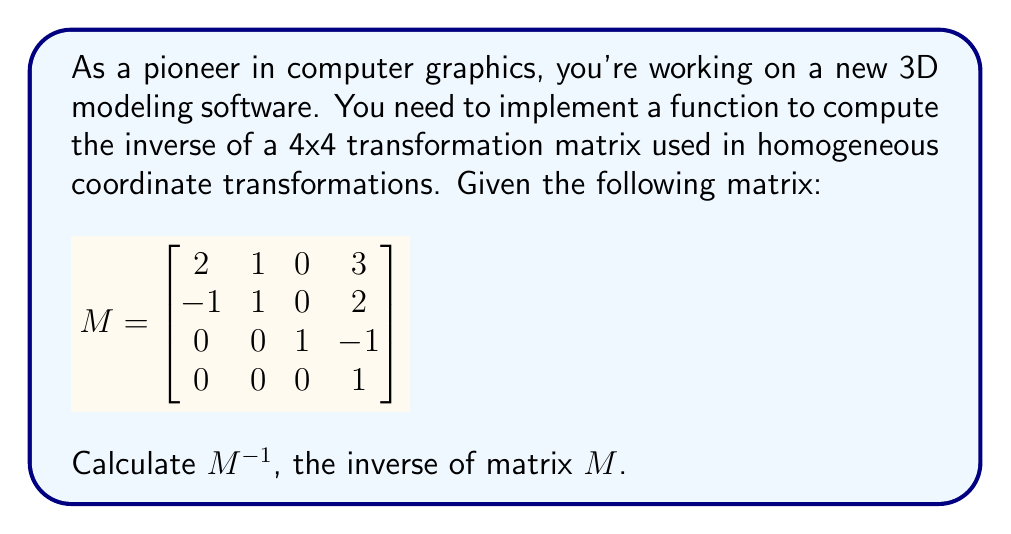Can you solve this math problem? To find the inverse of a 4x4 matrix, we can use the following steps:

1) First, we observe that $M$ is a special case of an affine transformation matrix, where the last row is $[0, 0, 0, 1]$. This allows us to use a more efficient method than the general inverse calculation.

2) We can partition the matrix into blocks:

   $$M = \begin{bmatrix} A & t \\ 0 & 1 \end{bmatrix}$$

   where $A$ is a 3x3 matrix, and $t$ is a 3x1 translation vector.

3) For this form, the inverse is given by:

   $$M^{-1} = \begin{bmatrix} A^{-1} & -A^{-1}t \\ 0 & 1 \end{bmatrix}$$

4) Let's find $A^{-1}$:

   $$A = \begin{bmatrix}
   2 & 1 & 0 \\
   -1 & 1 & 0 \\
   0 & 0 & 1
   \end{bmatrix}$$

5) We can see that $A$ is block diagonal, so we only need to invert the 2x2 upper-left block:

   $$\begin{bmatrix}
   2 & 1 \\
   -1 & 1
   \end{bmatrix}^{-1} = \frac{1}{3}\begin{bmatrix}
   1 & -1 \\
   1 & 2
   \end{bmatrix}$$

6) Therefore:

   $$A^{-1} = \begin{bmatrix}
   1/3 & -1/3 & 0 \\
   1/3 & 2/3 & 0 \\
   0 & 0 & 1
   \end{bmatrix}$$

7) Now, let's compute $-A^{-1}t$:

   $$-A^{-1}t = -\begin{bmatrix}
   1/3 & -1/3 & 0 \\
   1/3 & 2/3 & 0 \\
   0 & 0 & 1
   \end{bmatrix}\begin{bmatrix}
   3 \\
   2 \\
   -1
   \end{bmatrix} = \begin{bmatrix}
   -1/3 \\
   -5/3 \\
   1
   \end{bmatrix}$$

8) Putting it all together:

   $$M^{-1} = \begin{bmatrix}
   1/3 & -1/3 & 0 & -1/3 \\
   1/3 & 2/3 & 0 & -5/3 \\
   0 & 0 & 1 & 1 \\
   0 & 0 & 0 & 1
   \end{bmatrix}$$
Answer: $$M^{-1} = \begin{bmatrix}
1/3 & -1/3 & 0 & -1/3 \\
1/3 & 2/3 & 0 & -5/3 \\
0 & 0 & 1 & 1 \\
0 & 0 & 0 & 1
\end{bmatrix}$$ 